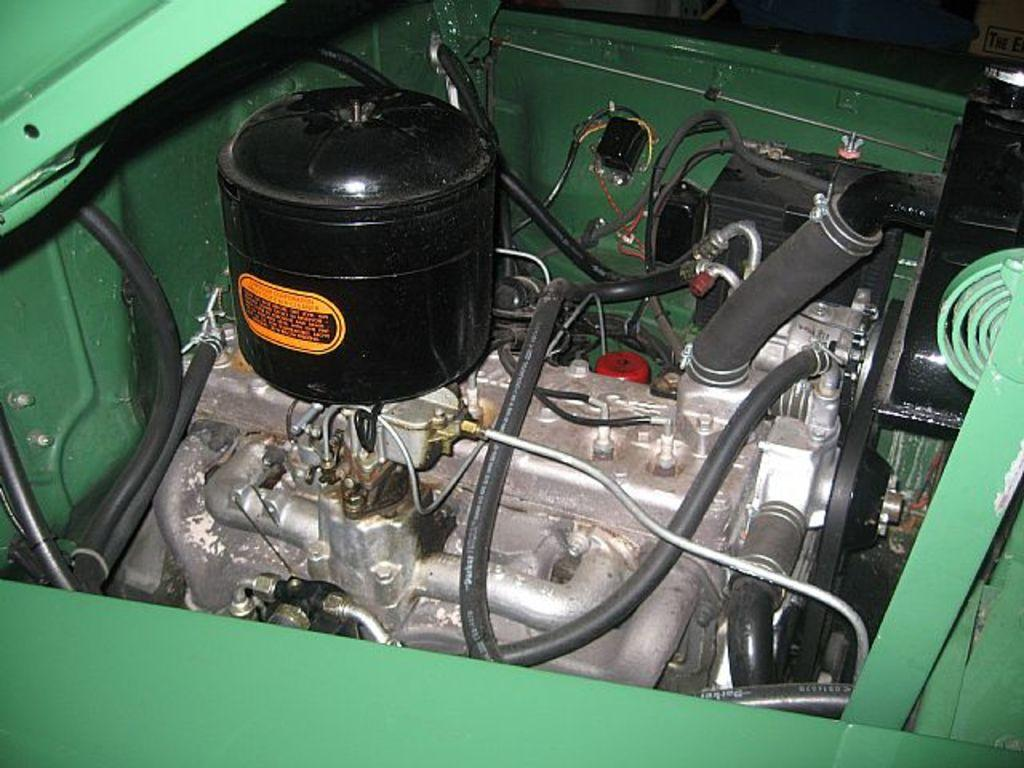What is the main subject of the picture? The main subject of the picture is an engine. Can you describe the object above the engine? There is a black color object above the engine. What type of barrier surrounds the engine? There is a green color fence around the engine. What type of sea creatures can be seen swimming near the engine in the image? There are no sea creatures present in the image, as it features an engine with a black object above it and a green fence surrounding it. 